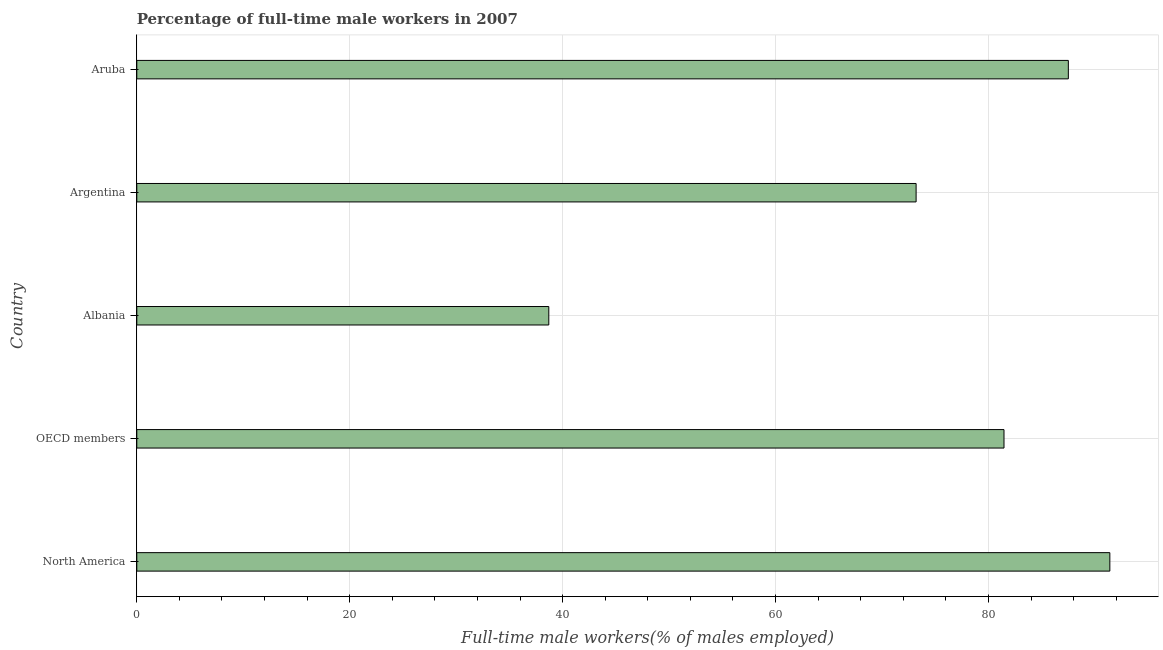Does the graph contain grids?
Provide a succinct answer. Yes. What is the title of the graph?
Keep it short and to the point. Percentage of full-time male workers in 2007. What is the label or title of the X-axis?
Provide a succinct answer. Full-time male workers(% of males employed). What is the percentage of full-time male workers in North America?
Ensure brevity in your answer.  91.4. Across all countries, what is the maximum percentage of full-time male workers?
Provide a short and direct response. 91.4. Across all countries, what is the minimum percentage of full-time male workers?
Give a very brief answer. 38.7. In which country was the percentage of full-time male workers maximum?
Your answer should be compact. North America. In which country was the percentage of full-time male workers minimum?
Your answer should be compact. Albania. What is the sum of the percentage of full-time male workers?
Keep it short and to the point. 372.25. What is the difference between the percentage of full-time male workers in Albania and North America?
Your response must be concise. -52.7. What is the average percentage of full-time male workers per country?
Offer a very short reply. 74.45. What is the median percentage of full-time male workers?
Make the answer very short. 81.46. In how many countries, is the percentage of full-time male workers greater than 16 %?
Provide a short and direct response. 5. What is the ratio of the percentage of full-time male workers in Argentina to that in North America?
Provide a succinct answer. 0.8. Is the percentage of full-time male workers in Argentina less than that in OECD members?
Provide a succinct answer. Yes. Is the difference between the percentage of full-time male workers in North America and OECD members greater than the difference between any two countries?
Your response must be concise. No. What is the difference between the highest and the second highest percentage of full-time male workers?
Your response must be concise. 3.9. Is the sum of the percentage of full-time male workers in North America and OECD members greater than the maximum percentage of full-time male workers across all countries?
Your answer should be compact. Yes. What is the difference between the highest and the lowest percentage of full-time male workers?
Make the answer very short. 52.7. In how many countries, is the percentage of full-time male workers greater than the average percentage of full-time male workers taken over all countries?
Your answer should be very brief. 3. Are all the bars in the graph horizontal?
Provide a short and direct response. Yes. What is the Full-time male workers(% of males employed) of North America?
Your answer should be compact. 91.4. What is the Full-time male workers(% of males employed) in OECD members?
Give a very brief answer. 81.46. What is the Full-time male workers(% of males employed) of Albania?
Ensure brevity in your answer.  38.7. What is the Full-time male workers(% of males employed) in Argentina?
Provide a short and direct response. 73.2. What is the Full-time male workers(% of males employed) in Aruba?
Offer a very short reply. 87.5. What is the difference between the Full-time male workers(% of males employed) in North America and OECD members?
Your answer should be very brief. 9.94. What is the difference between the Full-time male workers(% of males employed) in North America and Albania?
Make the answer very short. 52.7. What is the difference between the Full-time male workers(% of males employed) in North America and Argentina?
Give a very brief answer. 18.2. What is the difference between the Full-time male workers(% of males employed) in North America and Aruba?
Make the answer very short. 3.9. What is the difference between the Full-time male workers(% of males employed) in OECD members and Albania?
Your answer should be very brief. 42.76. What is the difference between the Full-time male workers(% of males employed) in OECD members and Argentina?
Offer a terse response. 8.26. What is the difference between the Full-time male workers(% of males employed) in OECD members and Aruba?
Your answer should be compact. -6.04. What is the difference between the Full-time male workers(% of males employed) in Albania and Argentina?
Offer a terse response. -34.5. What is the difference between the Full-time male workers(% of males employed) in Albania and Aruba?
Your response must be concise. -48.8. What is the difference between the Full-time male workers(% of males employed) in Argentina and Aruba?
Ensure brevity in your answer.  -14.3. What is the ratio of the Full-time male workers(% of males employed) in North America to that in OECD members?
Provide a succinct answer. 1.12. What is the ratio of the Full-time male workers(% of males employed) in North America to that in Albania?
Your response must be concise. 2.36. What is the ratio of the Full-time male workers(% of males employed) in North America to that in Argentina?
Offer a very short reply. 1.25. What is the ratio of the Full-time male workers(% of males employed) in North America to that in Aruba?
Provide a short and direct response. 1.04. What is the ratio of the Full-time male workers(% of males employed) in OECD members to that in Albania?
Your response must be concise. 2.1. What is the ratio of the Full-time male workers(% of males employed) in OECD members to that in Argentina?
Ensure brevity in your answer.  1.11. What is the ratio of the Full-time male workers(% of males employed) in OECD members to that in Aruba?
Ensure brevity in your answer.  0.93. What is the ratio of the Full-time male workers(% of males employed) in Albania to that in Argentina?
Your answer should be compact. 0.53. What is the ratio of the Full-time male workers(% of males employed) in Albania to that in Aruba?
Keep it short and to the point. 0.44. What is the ratio of the Full-time male workers(% of males employed) in Argentina to that in Aruba?
Your answer should be very brief. 0.84. 